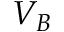Convert formula to latex. <formula><loc_0><loc_0><loc_500><loc_500>V _ { B }</formula> 